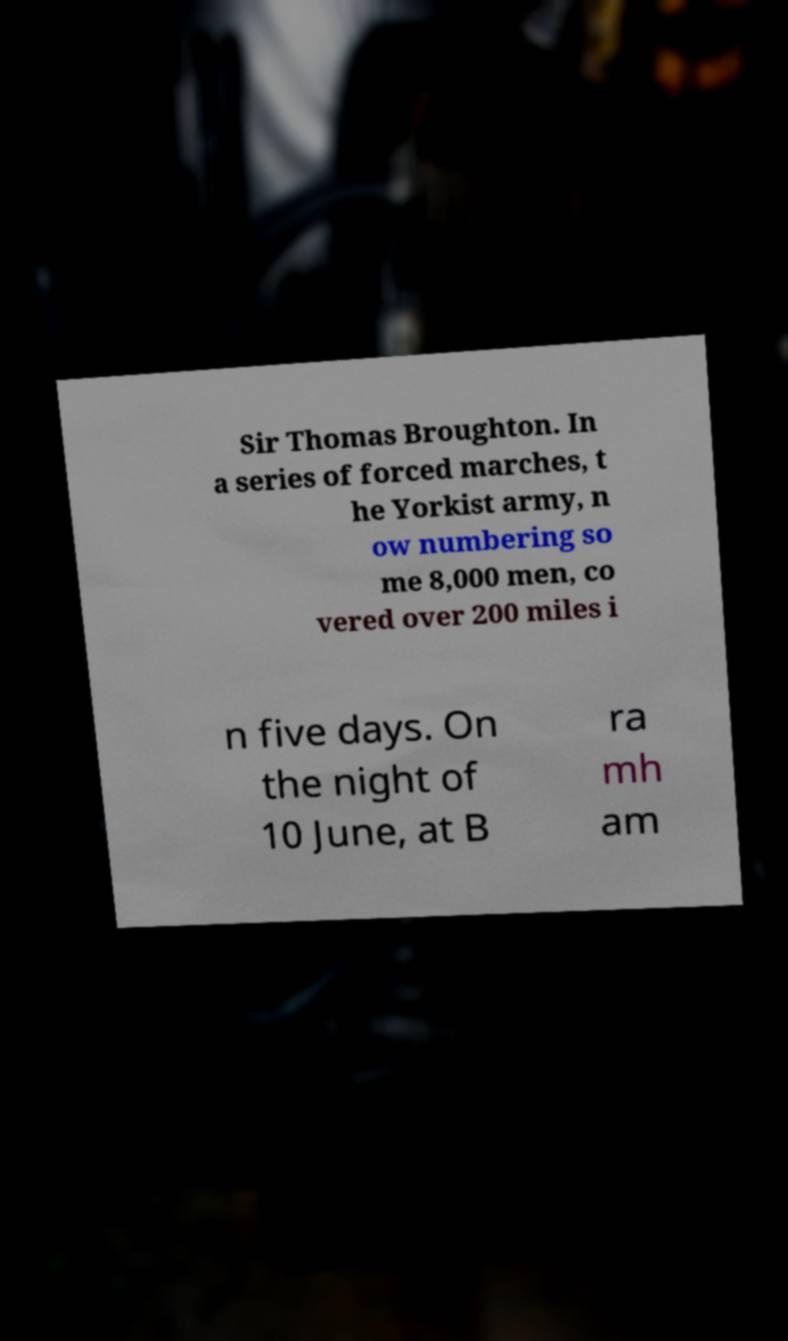Could you extract and type out the text from this image? Sir Thomas Broughton. In a series of forced marches, t he Yorkist army, n ow numbering so me 8,000 men, co vered over 200 miles i n five days. On the night of 10 June, at B ra mh am 